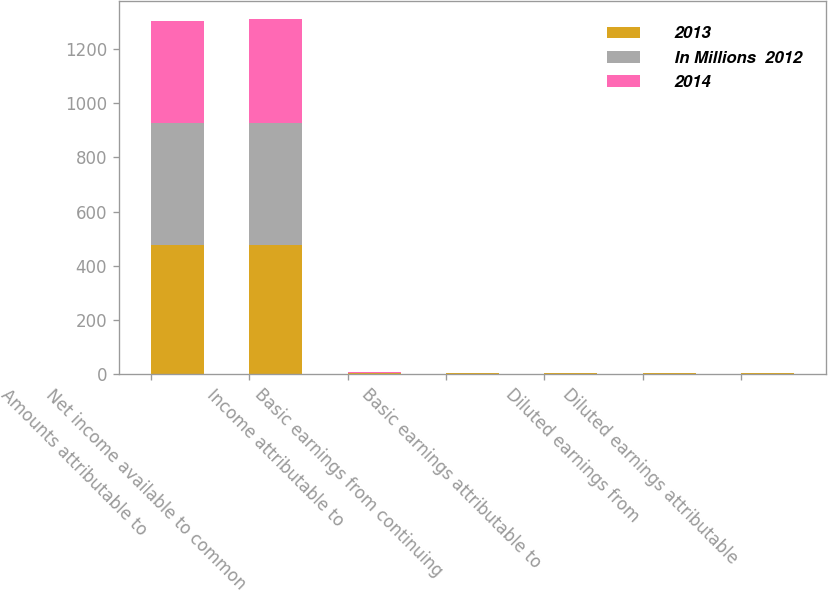Convert chart. <chart><loc_0><loc_0><loc_500><loc_500><stacked_bar_chart><ecel><fcel>Amounts attributable to<fcel>Net income available to common<fcel>Income attributable to<fcel>Basic earnings from continuing<fcel>Basic earnings attributable to<fcel>Diluted earnings from<fcel>Diluted earnings attributable<nl><fcel>2013<fcel>477<fcel>477<fcel>2<fcel>1.76<fcel>1.76<fcel>1.74<fcel>1.74<nl><fcel>In Millions  2012<fcel>452<fcel>452<fcel>2<fcel>1.71<fcel>1.71<fcel>1.66<fcel>1.66<nl><fcel>2014<fcel>375<fcel>382<fcel>2<fcel>1.43<fcel>1.46<fcel>1.39<fcel>1.42<nl></chart> 